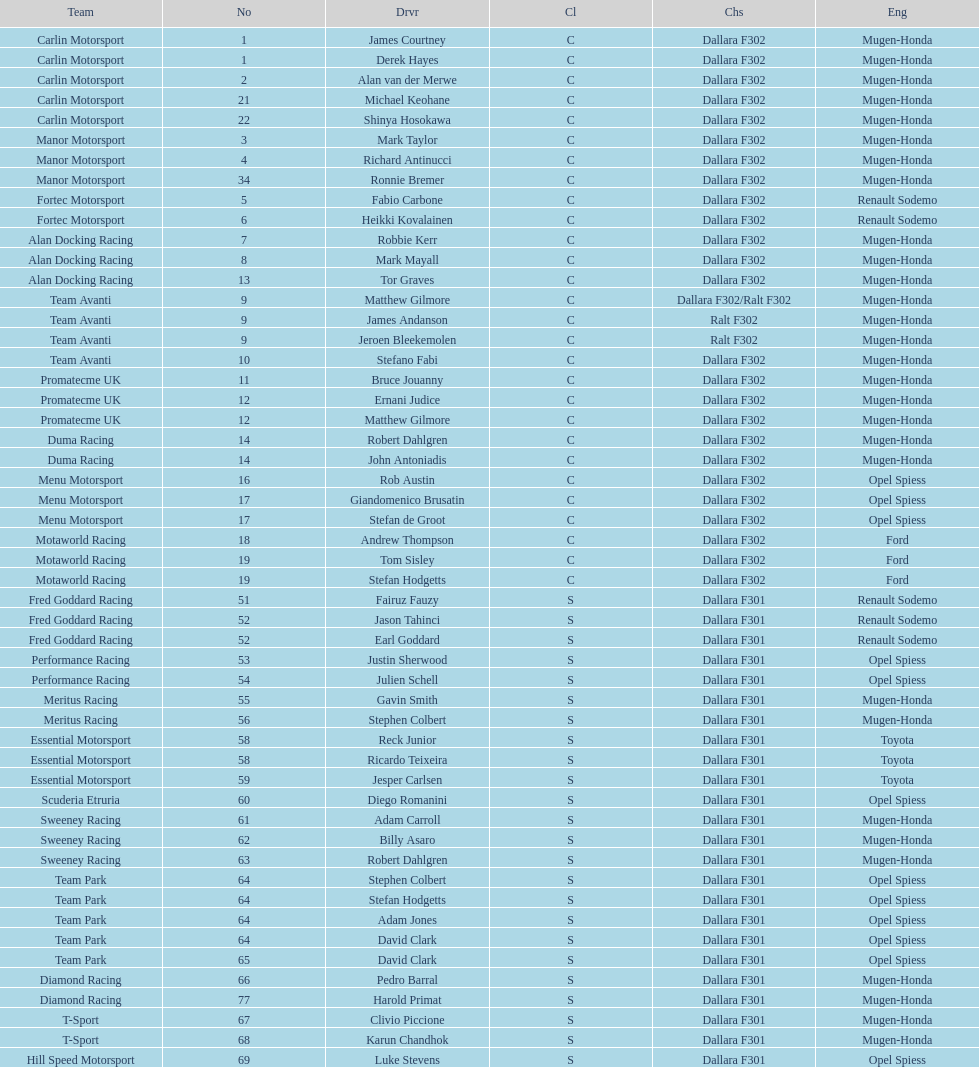What team is listed above diamond racing? Team Park. 